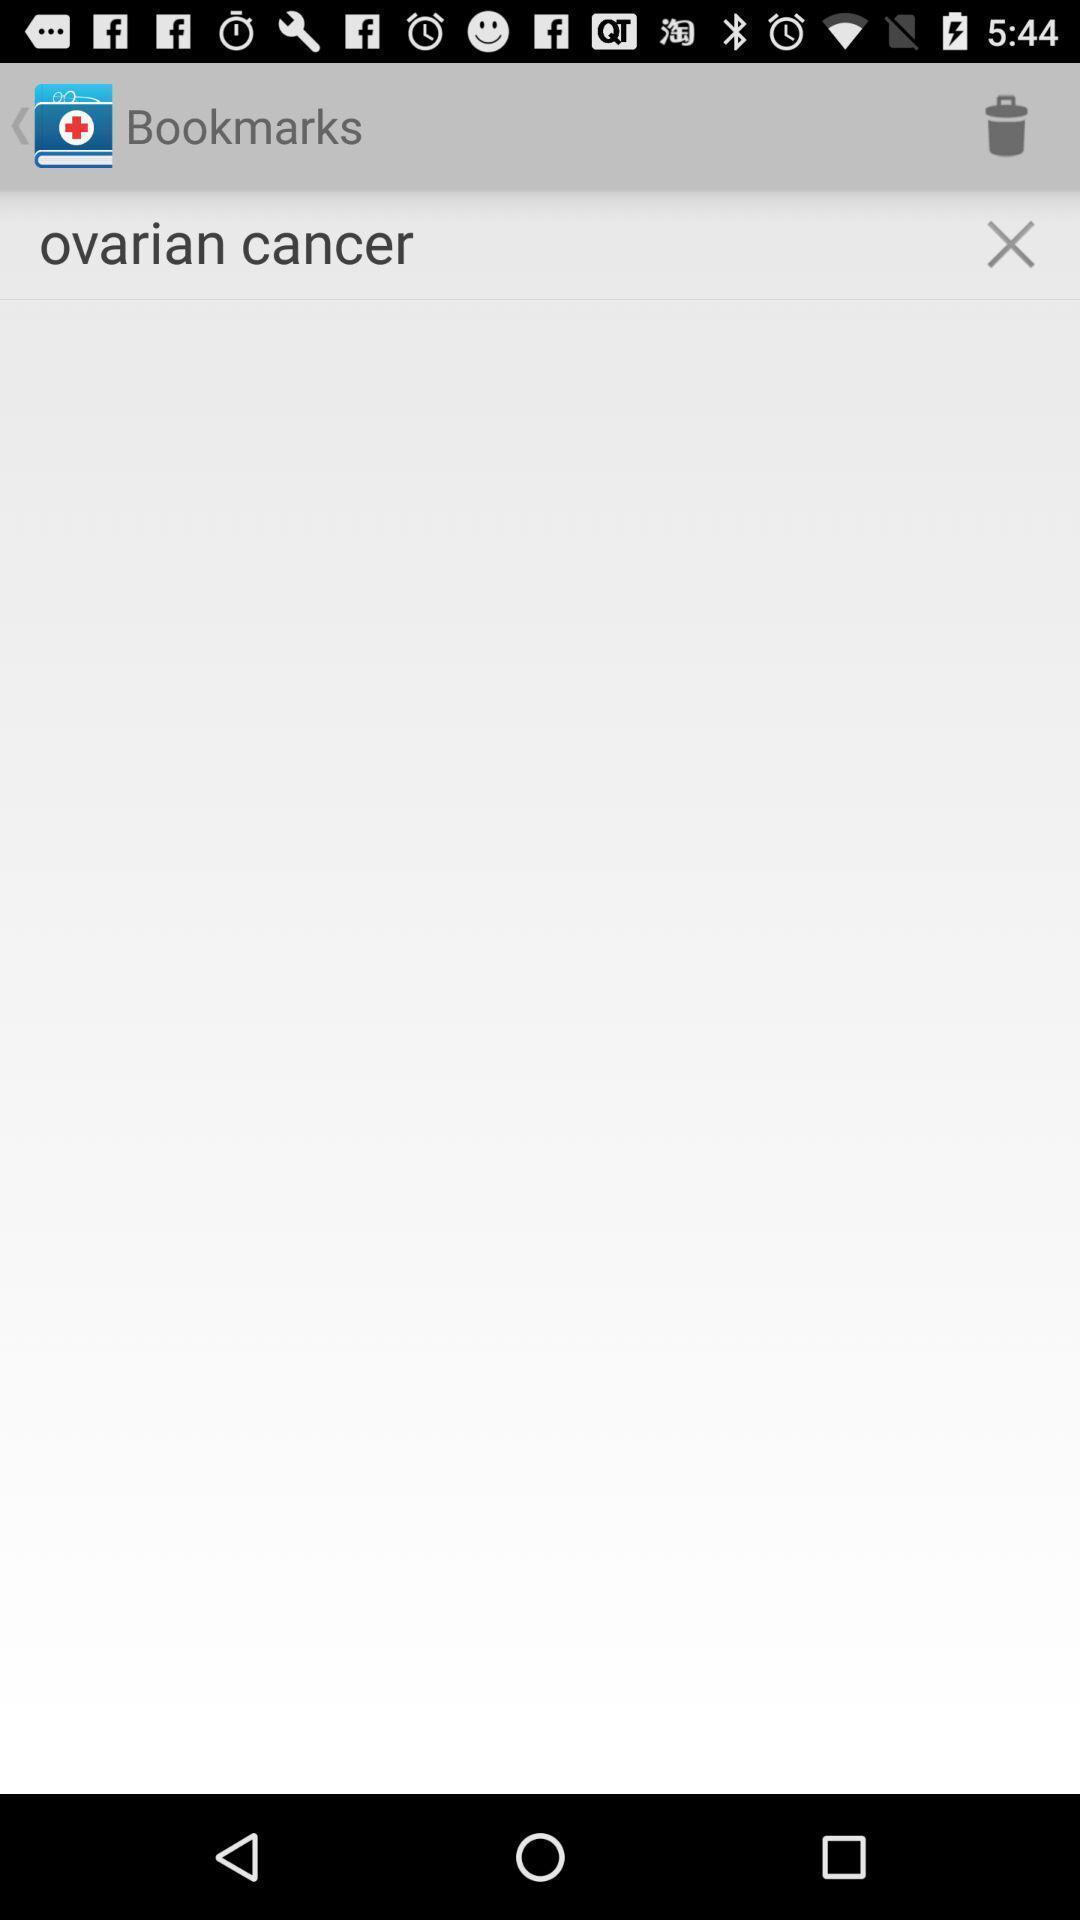Tell me about the visual elements in this screen capture. Screen page of health application. 